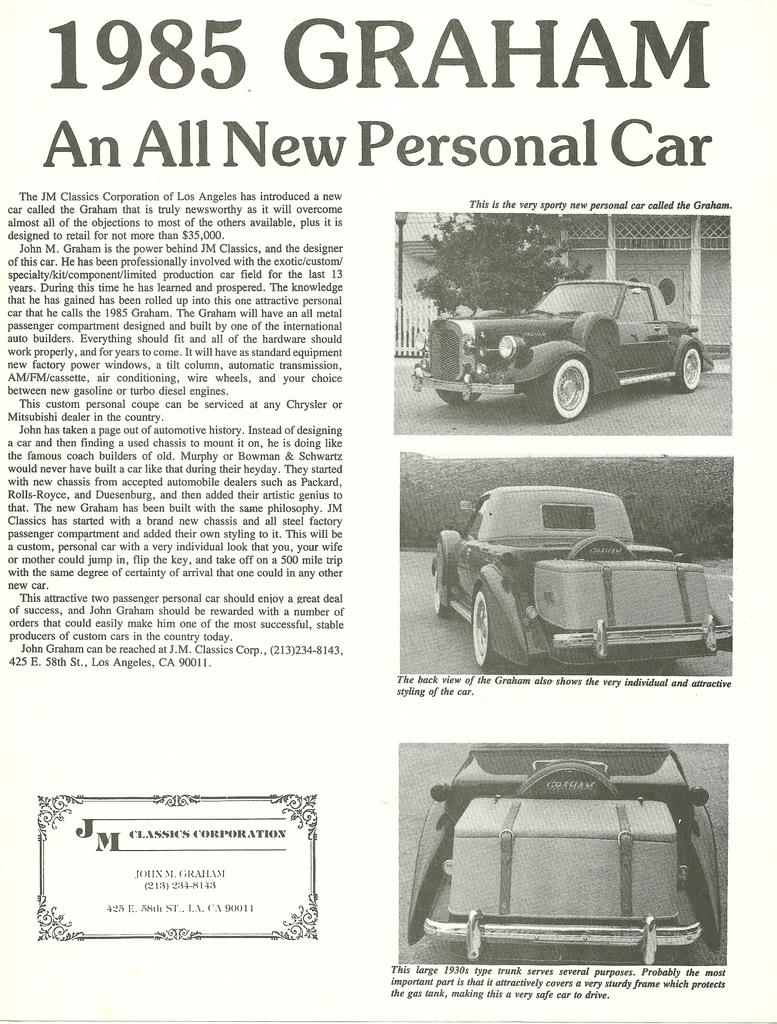What is the main subject of the image? The main subject of the image is a paper. What type of content is on the paper? The paper contains images of vehicles. What is the color scheme of the image? The image is in black and white. Are there any words on the paper? Yes, there is writing on the paper. What type of good-bye message can be seen written on the paper? There is no good-bye message present on the paper; it contains images of vehicles and writing. What type of verse is written on the paper? There is no verse present on the paper; it contains images of vehicles and writing. 